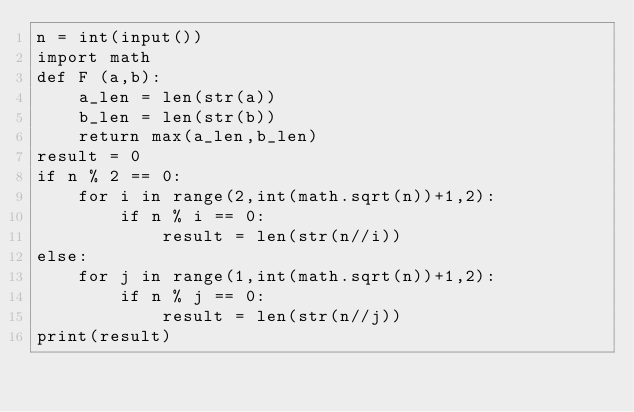Convert code to text. <code><loc_0><loc_0><loc_500><loc_500><_Python_>n = int(input())
import math
def F (a,b):
    a_len = len(str(a))
    b_len = len(str(b))
    return max(a_len,b_len)
result = 0
if n % 2 == 0:
    for i in range(2,int(math.sqrt(n))+1,2):
        if n % i == 0:
            result = len(str(n//i))
else:
    for j in range(1,int(math.sqrt(n))+1,2):
        if n % j == 0:
            result = len(str(n//j))
print(result)</code> 